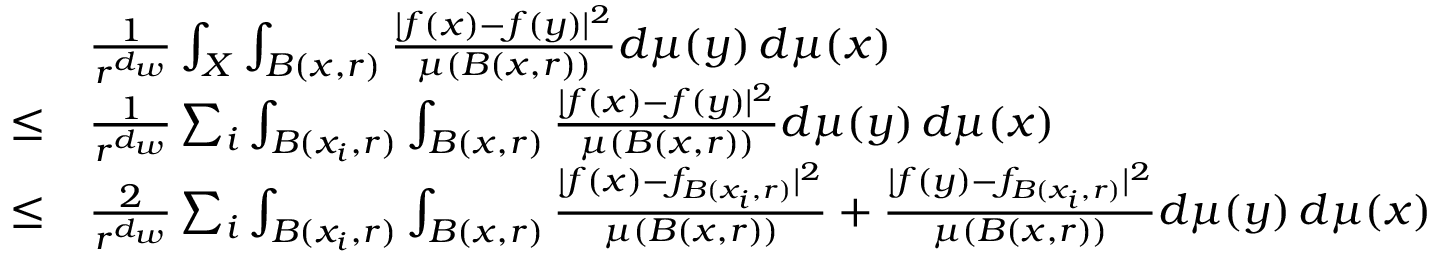Convert formula to latex. <formula><loc_0><loc_0><loc_500><loc_500>\begin{array} { r l } & { \frac { 1 } { r ^ { d _ { w } } } \int _ { X } \int _ { B ( x , r ) } \frac { | f ( x ) - f ( y ) | ^ { 2 } } { \mu ( B ( x , r ) ) } d \mu ( y ) \, d \mu ( x ) } \\ { \leq } & { \frac { 1 } { r ^ { d _ { w } } } \sum _ { i } \int _ { B ( x _ { i } , r ) } \int _ { B ( x , r ) } \frac { | f ( x ) - f ( y ) | ^ { 2 } } { \mu ( B ( x , r ) ) } d \mu ( y ) \, d \mu ( x ) } \\ { \leq } & { \frac { 2 } { r ^ { d _ { w } } } \sum _ { i } \int _ { B ( x _ { i } , r ) } \int _ { B ( x , r ) } \frac { | f ( x ) - f _ { B ( x _ { i } , r ) } | ^ { 2 } } { \mu ( B ( x , r ) ) } + \frac { | f ( y ) - f _ { B ( x _ { i } , r ) } | ^ { 2 } } { \mu ( B ( x , r ) ) } d \mu ( y ) \, d \mu ( x ) } \end{array}</formula> 